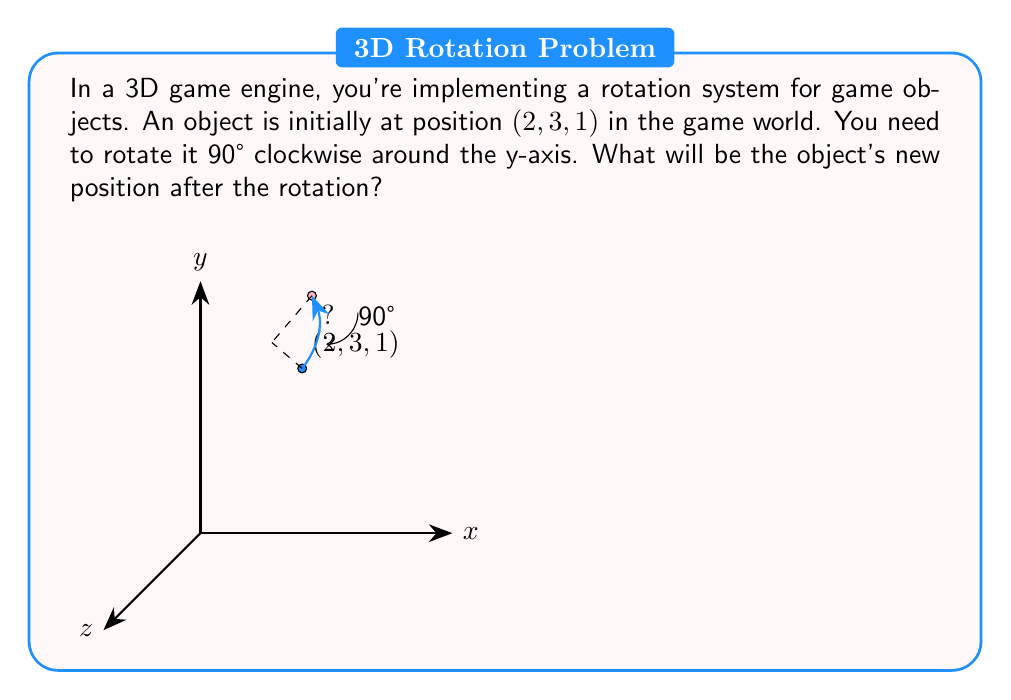What is the answer to this math problem? To solve this problem, we need to apply the rotation matrix for a 90° clockwise rotation around the y-axis. The steps are as follows:

1) The rotation matrix for a 90° clockwise rotation around the y-axis is:

   $$R_y(90°) = \begin{bmatrix}
   0 & 0 & 1 \\
   0 & 1 & 0 \\
   -1 & 0 & 0
   \end{bmatrix}$$

2) We need to multiply this matrix by the initial position vector:

   $$\begin{bmatrix}
   0 & 0 & 1 \\
   0 & 1 & 0 \\
   -1 & 0 & 0
   \end{bmatrix} \cdot \begin{bmatrix}
   2 \\
   3 \\
   1
   \end{bmatrix}$$

3) Performing the matrix multiplication:

   $$\begin{aligned}
   x' &= 0(2) + 0(3) + 1(1) = 1 \\
   y' &= 0(2) + 1(3) + 0(1) = 3 \\
   z' &= -1(2) + 0(3) + 0(1) = -2
   \end{aligned}$$

4) Therefore, the new position after rotation is $(1, 3, -2)$.

This rotation effectively moves the object from the first quadrant to the fourth quadrant in the xz-plane, while maintaining its y-coordinate.
Answer: $(1, 3, -2)$ 